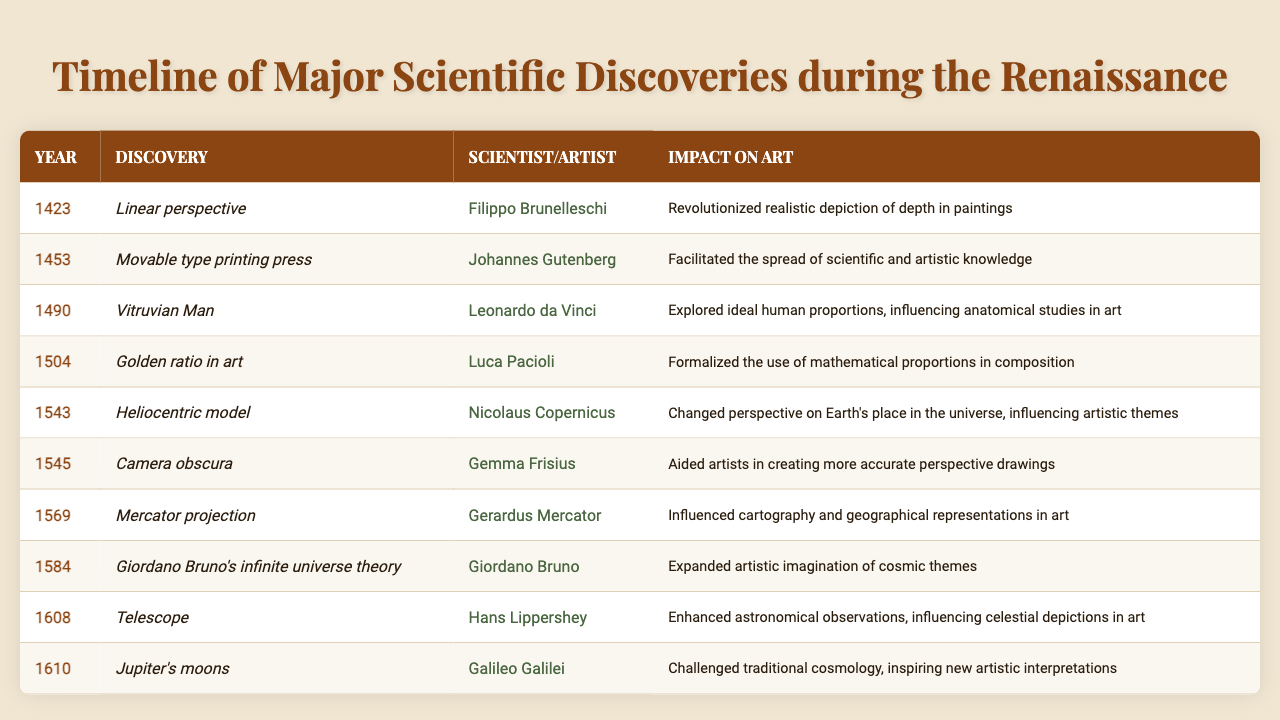What year was the invention of the movable type printing press? The table lists the discovery of the movable type printing press with the year 1453.
Answer: 1453 Who discovered the heliocentric model, and in what year? Referring to the table, the heliocentric model was discovered by Nicolaus Copernicus in 1543.
Answer: Nicolaus Copernicus, 1543 What was the impact of the linear perspective on art? The table states that linear perspective revolutionized the realistic depiction of depth in paintings.
Answer: Revolutionized realistic depiction of depth in paintings How many discoveries listed were made before 1500? By counting the entries from the table, there are four discoveries made before the year 1500 (1423, 1453, 1490, and 1504).
Answer: 4 Which discovery had the earliest year, and who was the scientist? The earliest year in the timeline is 1423, with Filippo Brunelleschi being the scientist who discovered linear perspective.
Answer: Linear perspective, Filippo Brunelleschi Did the discovery of the camera obscura influence art? Yes, the table notes that the camera obscura aided artists in creating more accurate perspective drawings.
Answer: Yes What is the sum of the years of the last three discoveries? The last three discoveries are in the years 1584, 1608, and 1610. Adding these together gives us 1584 + 1608 + 1610 = 4802.
Answer: 4802 Which scientist contributed to the Mercator projection? According to the table, Gerardus Mercator contributed to the Mercator projection.
Answer: Gerardus Mercator What was the impact of Giordano Bruno's theory on art? Giordano Bruno's infinite universe theory expanded the artistic imagination of cosmic themes, as indicated in the table.
Answer: Expanded artistic imagination of cosmic themes In what way did the telescope influence art? The table indicates that the telescope enhanced astronomical observations, which influenced celestial depictions in art.
Answer: Enhanced astronomical observations, influencing celestial depictions in art 